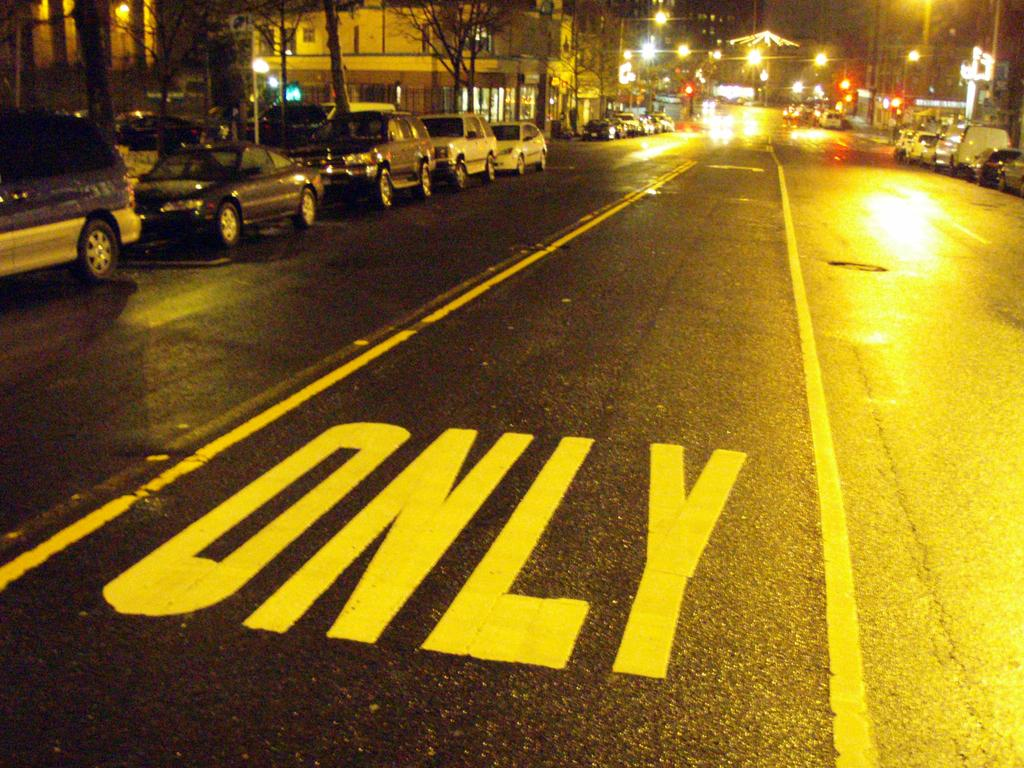<image>
Render a clear and concise summary of the photo. A clear street has only painted on the lane. 